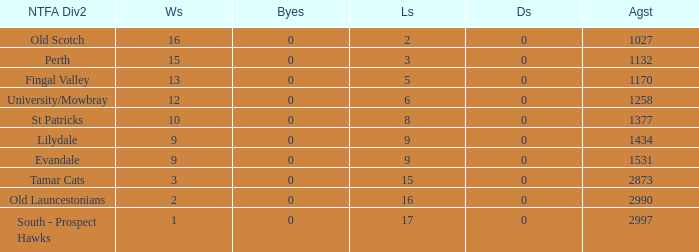What is the lowest number of draws of the NTFA Div 2 Lilydale? 0.0. 